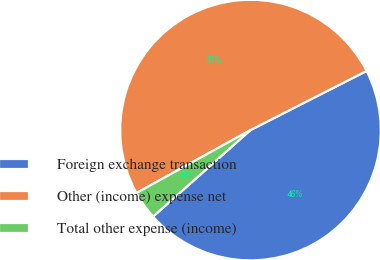Convert chart to OTSL. <chart><loc_0><loc_0><loc_500><loc_500><pie_chart><fcel>Foreign exchange transaction<fcel>Other (income) expense net<fcel>Total other expense (income)<nl><fcel>45.94%<fcel>50.53%<fcel>3.53%<nl></chart> 